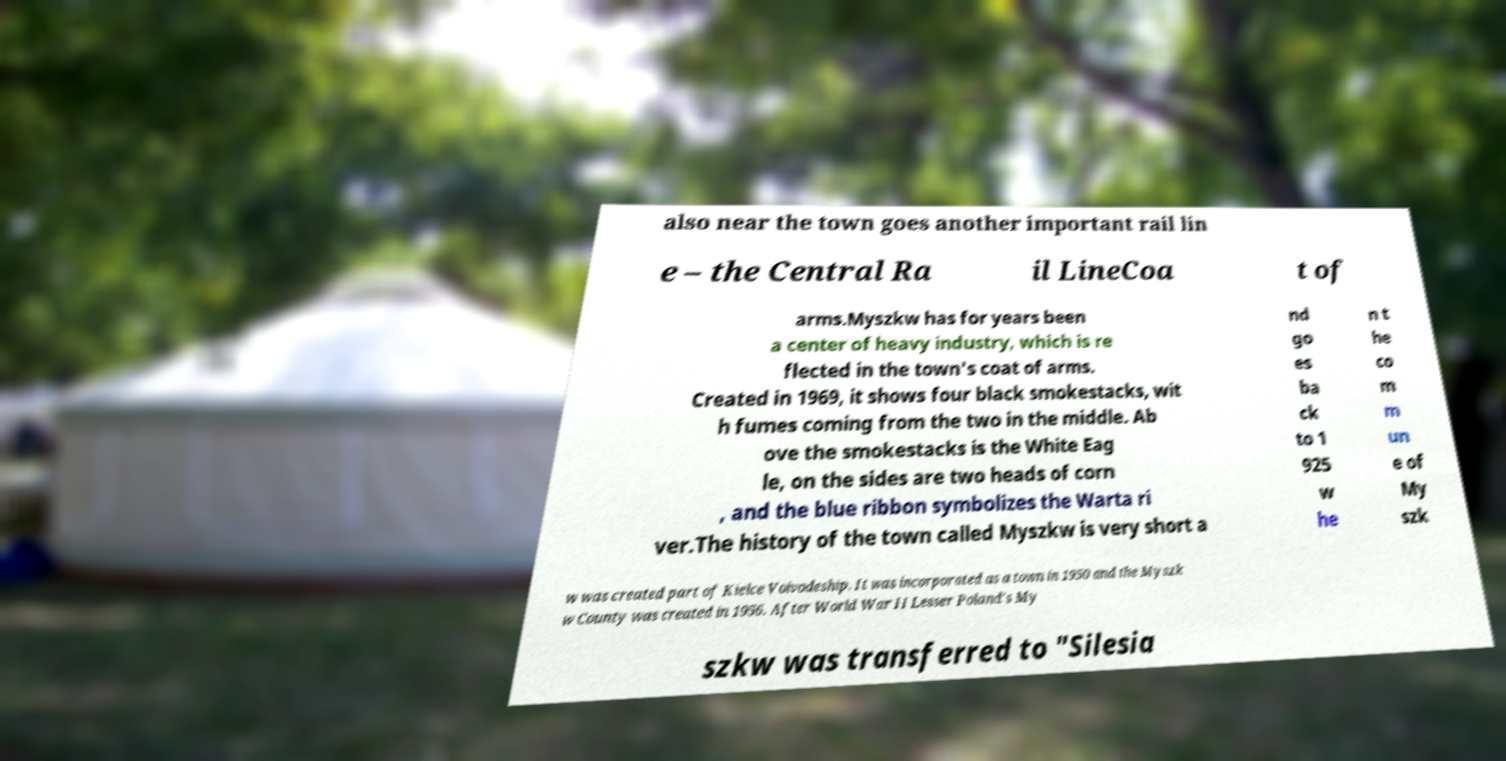Could you extract and type out the text from this image? also near the town goes another important rail lin e – the Central Ra il LineCoa t of arms.Myszkw has for years been a center of heavy industry, which is re flected in the town's coat of arms. Created in 1969, it shows four black smokestacks, wit h fumes coming from the two in the middle. Ab ove the smokestacks is the White Eag le, on the sides are two heads of corn , and the blue ribbon symbolizes the Warta ri ver.The history of the town called Myszkw is very short a nd go es ba ck to 1 925 w he n t he co m m un e of My szk w was created part of Kielce Voivodeship. It was incorporated as a town in 1950 and the Myszk w County was created in 1956. After World War II Lesser Poland's My szkw was transferred to "Silesia 